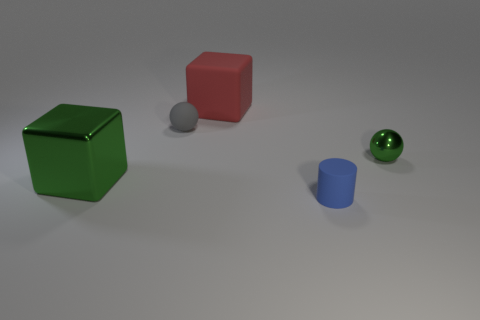Are there any other things that are the same shape as the tiny blue matte thing?
Offer a very short reply. No. Is the number of large matte objects that are to the right of the small blue rubber object less than the number of large objects that are behind the gray ball?
Your response must be concise. Yes. There is a large object that is made of the same material as the tiny blue thing; what color is it?
Offer a very short reply. Red. There is a big cube that is on the right side of the gray sphere; are there any small green things that are in front of it?
Your answer should be very brief. Yes. The shiny sphere that is the same size as the gray rubber object is what color?
Your answer should be compact. Green. How many objects are small blue rubber cylinders or yellow metal balls?
Provide a short and direct response. 1. What size is the thing that is behind the small object left of the block that is to the right of the green metal block?
Your response must be concise. Large. How many shiny spheres have the same color as the shiny block?
Your response must be concise. 1. How many green balls have the same material as the small blue cylinder?
Keep it short and to the point. 0. What number of objects are either red matte things or tiny green metal things that are behind the big green metal thing?
Provide a succinct answer. 2. 